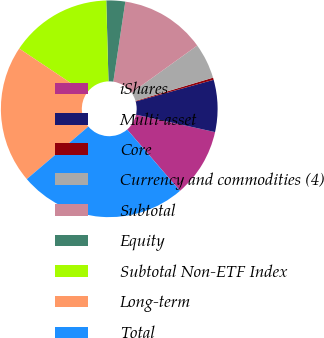Convert chart to OTSL. <chart><loc_0><loc_0><loc_500><loc_500><pie_chart><fcel>iShares<fcel>Multi-asset<fcel>Core<fcel>Currency and commodities (4)<fcel>Subtotal<fcel>Equity<fcel>Subtotal Non-ETF Index<fcel>Long-term<fcel>Total<nl><fcel>10.23%<fcel>7.76%<fcel>0.33%<fcel>5.28%<fcel>12.71%<fcel>2.81%<fcel>15.18%<fcel>20.62%<fcel>25.08%<nl></chart> 